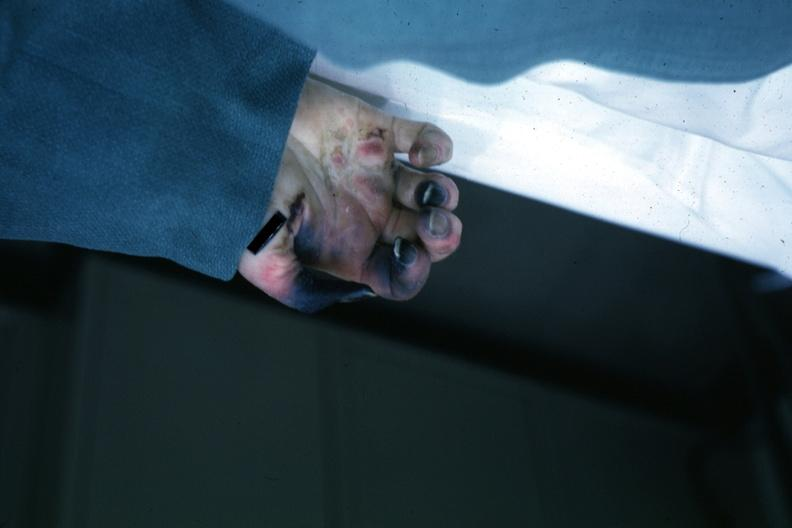re extremities present?
Answer the question using a single word or phrase. Yes 